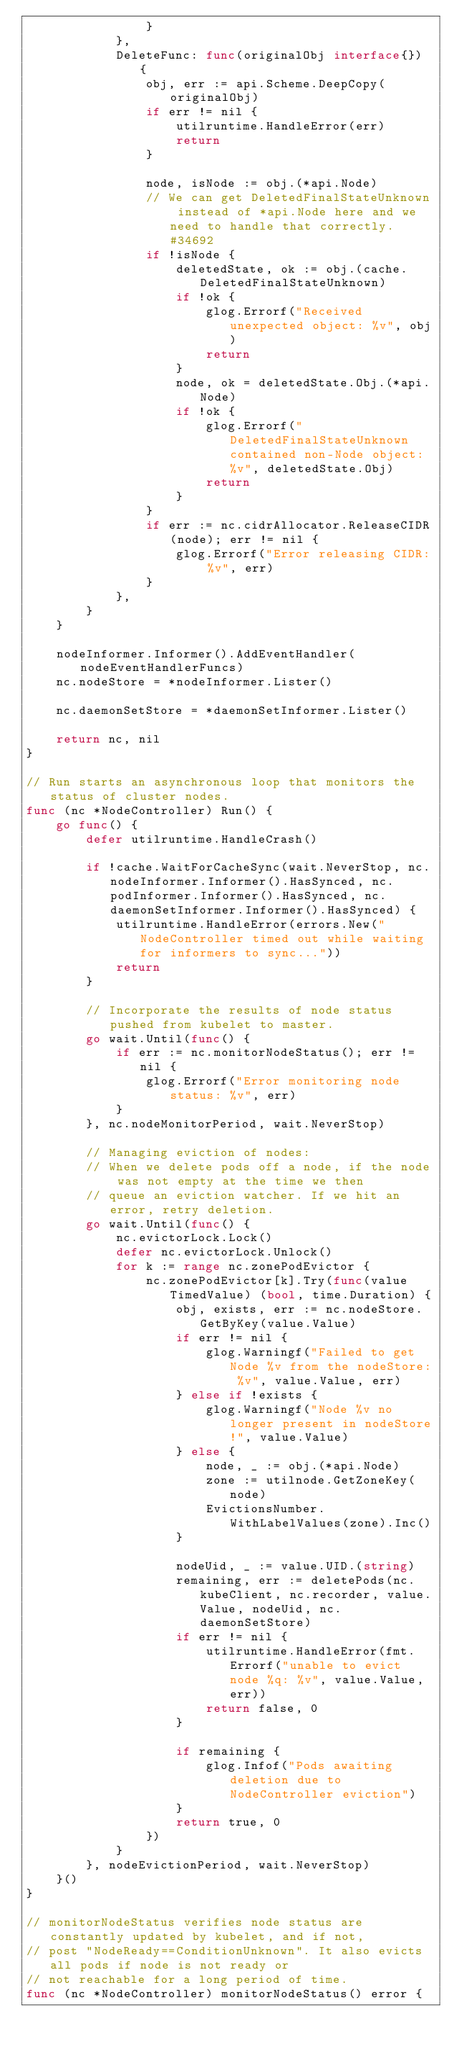Convert code to text. <code><loc_0><loc_0><loc_500><loc_500><_Go_>				}
			},
			DeleteFunc: func(originalObj interface{}) {
				obj, err := api.Scheme.DeepCopy(originalObj)
				if err != nil {
					utilruntime.HandleError(err)
					return
				}

				node, isNode := obj.(*api.Node)
				// We can get DeletedFinalStateUnknown instead of *api.Node here and we need to handle that correctly. #34692
				if !isNode {
					deletedState, ok := obj.(cache.DeletedFinalStateUnknown)
					if !ok {
						glog.Errorf("Received unexpected object: %v", obj)
						return
					}
					node, ok = deletedState.Obj.(*api.Node)
					if !ok {
						glog.Errorf("DeletedFinalStateUnknown contained non-Node object: %v", deletedState.Obj)
						return
					}
				}
				if err := nc.cidrAllocator.ReleaseCIDR(node); err != nil {
					glog.Errorf("Error releasing CIDR: %v", err)
				}
			},
		}
	}

	nodeInformer.Informer().AddEventHandler(nodeEventHandlerFuncs)
	nc.nodeStore = *nodeInformer.Lister()

	nc.daemonSetStore = *daemonSetInformer.Lister()

	return nc, nil
}

// Run starts an asynchronous loop that monitors the status of cluster nodes.
func (nc *NodeController) Run() {
	go func() {
		defer utilruntime.HandleCrash()

		if !cache.WaitForCacheSync(wait.NeverStop, nc.nodeInformer.Informer().HasSynced, nc.podInformer.Informer().HasSynced, nc.daemonSetInformer.Informer().HasSynced) {
			utilruntime.HandleError(errors.New("NodeController timed out while waiting for informers to sync..."))
			return
		}

		// Incorporate the results of node status pushed from kubelet to master.
		go wait.Until(func() {
			if err := nc.monitorNodeStatus(); err != nil {
				glog.Errorf("Error monitoring node status: %v", err)
			}
		}, nc.nodeMonitorPeriod, wait.NeverStop)

		// Managing eviction of nodes:
		// When we delete pods off a node, if the node was not empty at the time we then
		// queue an eviction watcher. If we hit an error, retry deletion.
		go wait.Until(func() {
			nc.evictorLock.Lock()
			defer nc.evictorLock.Unlock()
			for k := range nc.zonePodEvictor {
				nc.zonePodEvictor[k].Try(func(value TimedValue) (bool, time.Duration) {
					obj, exists, err := nc.nodeStore.GetByKey(value.Value)
					if err != nil {
						glog.Warningf("Failed to get Node %v from the nodeStore: %v", value.Value, err)
					} else if !exists {
						glog.Warningf("Node %v no longer present in nodeStore!", value.Value)
					} else {
						node, _ := obj.(*api.Node)
						zone := utilnode.GetZoneKey(node)
						EvictionsNumber.WithLabelValues(zone).Inc()
					}

					nodeUid, _ := value.UID.(string)
					remaining, err := deletePods(nc.kubeClient, nc.recorder, value.Value, nodeUid, nc.daemonSetStore)
					if err != nil {
						utilruntime.HandleError(fmt.Errorf("unable to evict node %q: %v", value.Value, err))
						return false, 0
					}

					if remaining {
						glog.Infof("Pods awaiting deletion due to NodeController eviction")
					}
					return true, 0
				})
			}
		}, nodeEvictionPeriod, wait.NeverStop)
	}()
}

// monitorNodeStatus verifies node status are constantly updated by kubelet, and if not,
// post "NodeReady==ConditionUnknown". It also evicts all pods if node is not ready or
// not reachable for a long period of time.
func (nc *NodeController) monitorNodeStatus() error {</code> 